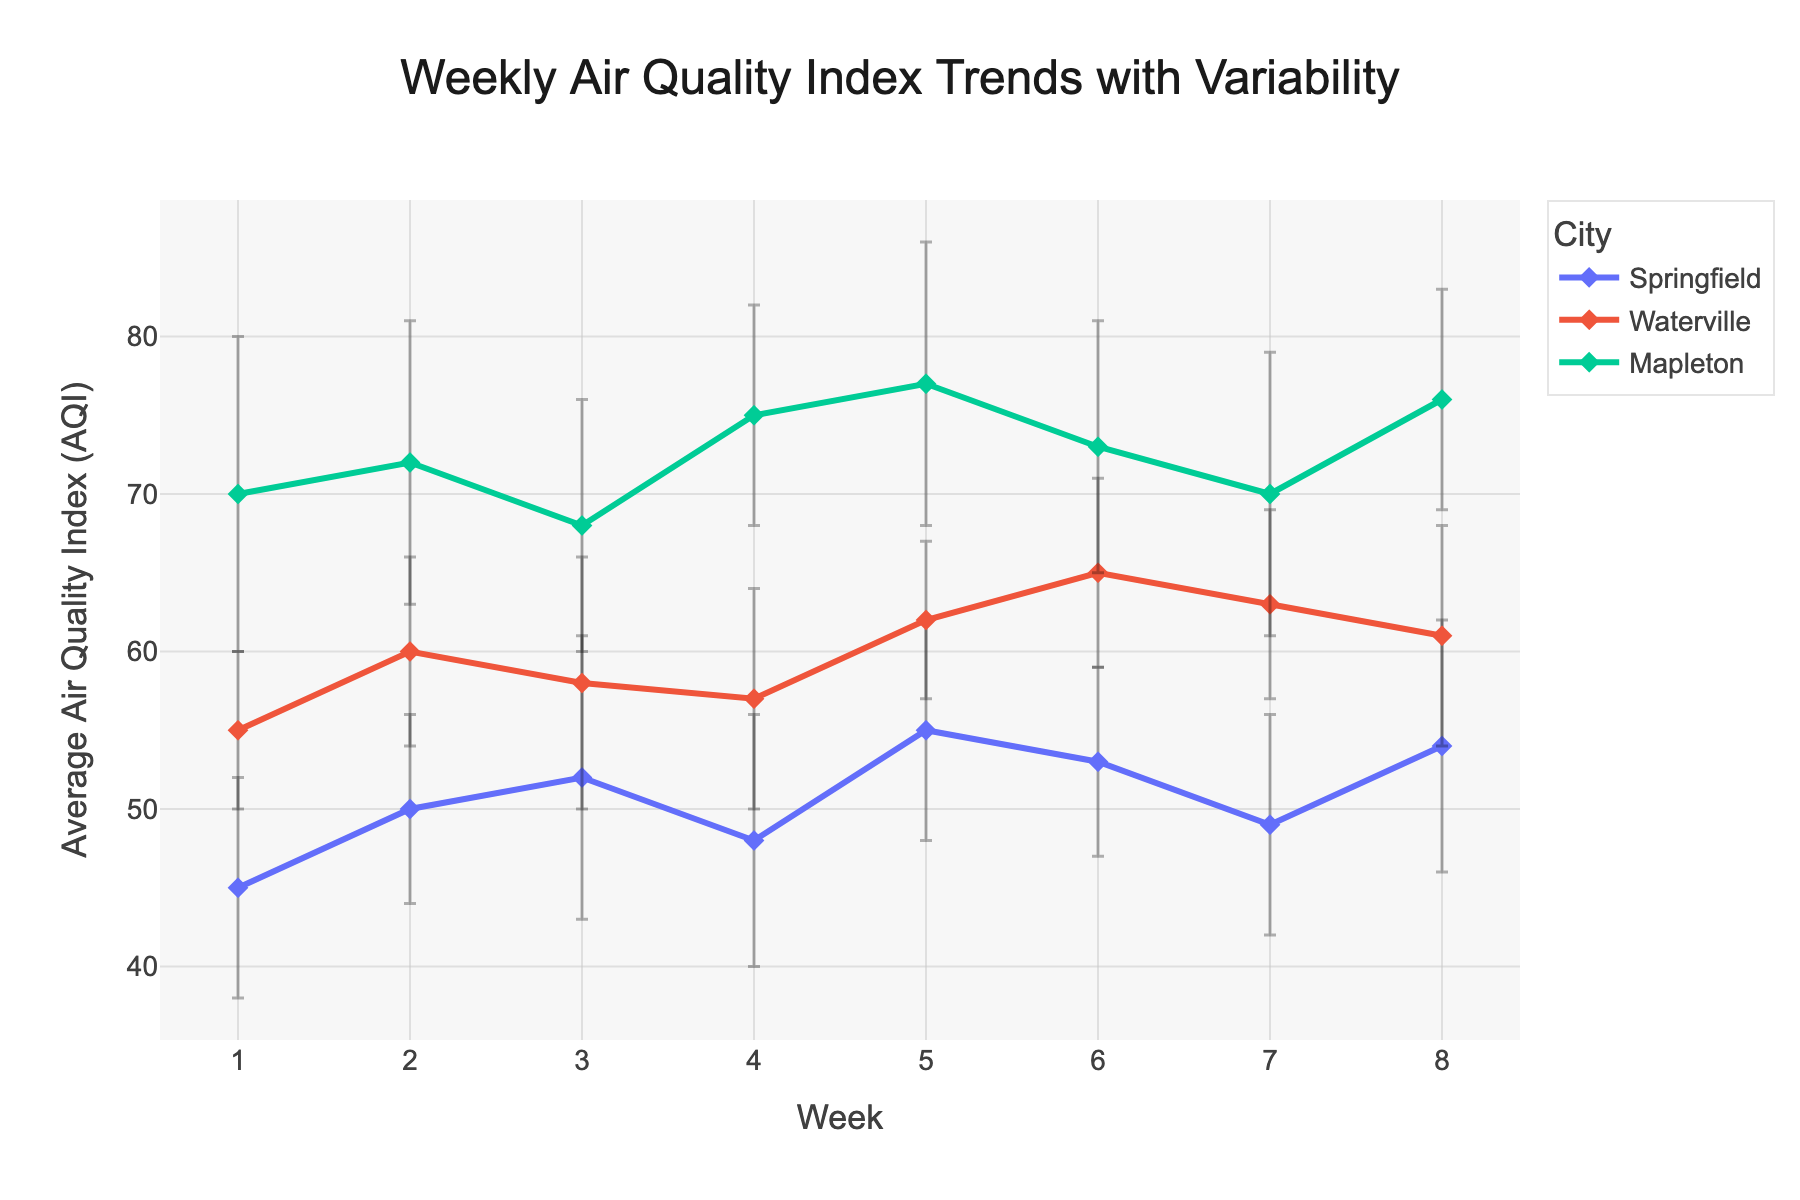Which city has the highest average AQI in week 4? To find the answer, look at the data points (markers) at week 4 across all cities and identify which one is the highest. The marker for Mapleton is at 75, higher than Springfield (48) and Waterville (57).
Answer: Mapleton What is the range of Springfield's AQI values? The range is determined by subtracting the minimum AQI value from the maximum AQI value for Springfield. The maximum value is 55 (week 5) and the minimum is 45 (week 1). Thus, the range is 55 - 45.
Answer: 10 Which city shows the most variability in AQI values across all weeks? Variability can be assessed by looking at the size of the error bars. Mapleton consistently has larger error bars, indicating greater variability compared to Springfield and Waterville.
Answer: Mapleton Between weeks 2 and 6, which city had the most improvement in AQI? Improvement in AQI means a decrease in values. Between weeks 2 and 6, Springfield's AQI changed from 50 to 53 (+3), Waterville from 60 to 65 (+5), and Mapleton from 72 to 73 (+1). Since Waterville increased its AQI the most, there was no improvement. All cities showed higher AQI (worse air quality), so no city improved.
Answer: None What is the average AQI for Waterville over the 8 weeks? Sum up Waterville's AQI values and divide by the number of weeks. (55 + 60 + 58 + 57 + 62 + 65 + 63 + 61) / 8 = 61.375.
Answer: 61.375 Did Springfield or Waterville have a greater AQI in week 7? Look at the AQI values for Springfield and Waterville in week 7. Springfield's AQI is 49, while Waterville's is 63. Waterville has a higher AQI.
Answer: Waterville Which week had the smallest variability in AQI for all cities? Smallest variability means the smallest error bars. By visual inspection, week 5 seems to have the smallest error bars across all cities.
Answer: Week 5 How does Mapleton's week 1 AQI compare to Springfield's week 8 AQI? Compare the week 1 AQI of Mapleton (70) with the week 8 AQI of Springfield (54). Mapleton's AQI is higher.
Answer: Mapleton's AQI is higher What is the highest AQI recorded among all cities and weeks? Scan through the AQIs of all cities and weeks and locate the maximum value. The highest recorded AQI is Mapleton in week 5 (77).
Answer: 77 Which city had the lowest AQI in any week, and what was that value? Identify the lowest data point in the plot. Springfield in week 1 has an AQI of 45, which is the lowest.
Answer: Springfield with 45 